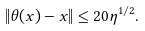Convert formula to latex. <formula><loc_0><loc_0><loc_500><loc_500>\| \theta ( x ) - x \| \leq 2 0 \eta ^ { 1 / 2 } .</formula> 